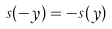Convert formula to latex. <formula><loc_0><loc_0><loc_500><loc_500>s ( - y ) = - s ( y )</formula> 